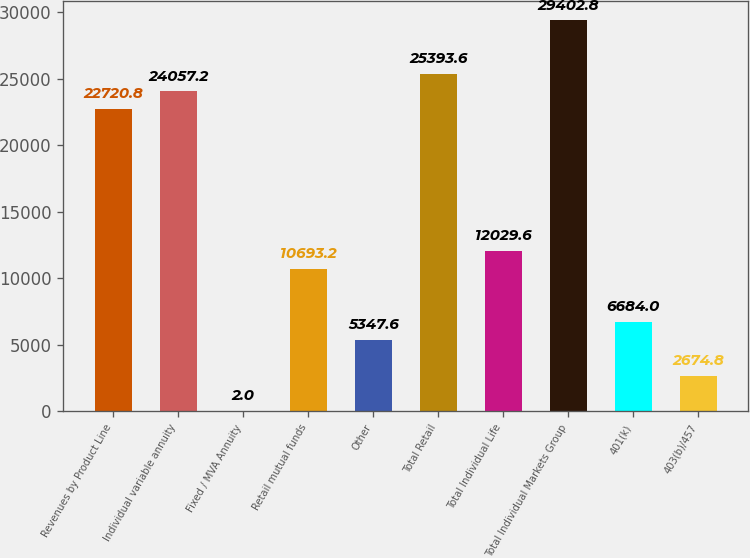Convert chart to OTSL. <chart><loc_0><loc_0><loc_500><loc_500><bar_chart><fcel>Revenues by Product Line<fcel>Individual variable annuity<fcel>Fixed / MVA Annuity<fcel>Retail mutual funds<fcel>Other<fcel>Total Retail<fcel>Total Individual Life<fcel>Total Individual Markets Group<fcel>401(k)<fcel>403(b)/457<nl><fcel>22720.8<fcel>24057.2<fcel>2<fcel>10693.2<fcel>5347.6<fcel>25393.6<fcel>12029.6<fcel>29402.8<fcel>6684<fcel>2674.8<nl></chart> 